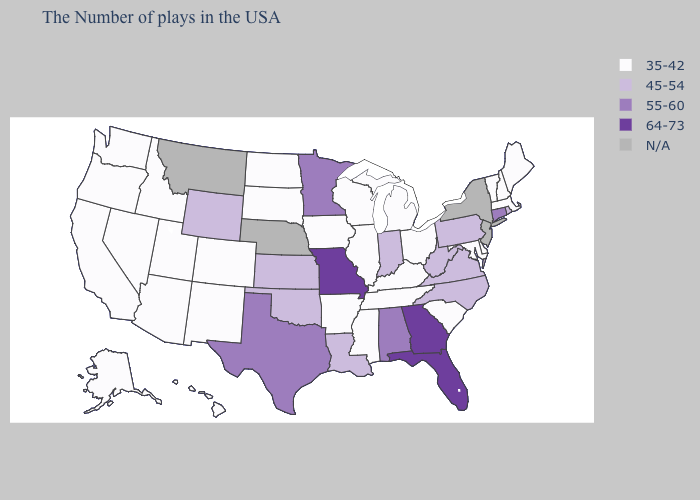What is the value of Alabama?
Keep it brief. 55-60. What is the highest value in the USA?
Give a very brief answer. 64-73. Among the states that border New Mexico , which have the lowest value?
Concise answer only. Colorado, Utah, Arizona. What is the value of South Carolina?
Answer briefly. 35-42. Name the states that have a value in the range 35-42?
Be succinct. Maine, Massachusetts, New Hampshire, Vermont, Delaware, Maryland, South Carolina, Ohio, Michigan, Kentucky, Tennessee, Wisconsin, Illinois, Mississippi, Arkansas, Iowa, South Dakota, North Dakota, Colorado, New Mexico, Utah, Arizona, Idaho, Nevada, California, Washington, Oregon, Alaska, Hawaii. Name the states that have a value in the range 64-73?
Write a very short answer. Florida, Georgia, Missouri. Which states hav the highest value in the MidWest?
Give a very brief answer. Missouri. What is the lowest value in the USA?
Give a very brief answer. 35-42. What is the lowest value in states that border Washington?
Answer briefly. 35-42. What is the highest value in the MidWest ?
Be succinct. 64-73. What is the highest value in states that border Arkansas?
Keep it brief. 64-73. Among the states that border South Dakota , which have the lowest value?
Write a very short answer. Iowa, North Dakota. Name the states that have a value in the range 55-60?
Concise answer only. Connecticut, Alabama, Minnesota, Texas. Name the states that have a value in the range 45-54?
Answer briefly. Rhode Island, Pennsylvania, Virginia, North Carolina, West Virginia, Indiana, Louisiana, Kansas, Oklahoma, Wyoming. Among the states that border Illinois , which have the lowest value?
Write a very short answer. Kentucky, Wisconsin, Iowa. 